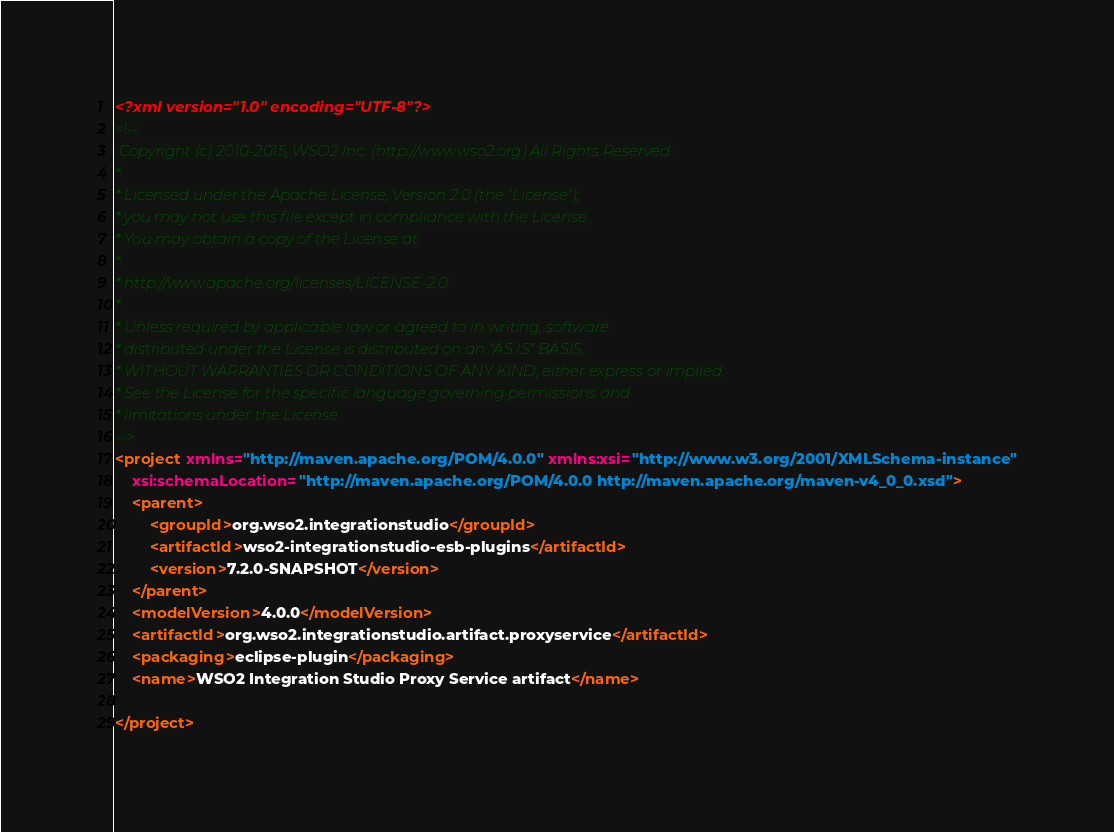Convert code to text. <code><loc_0><loc_0><loc_500><loc_500><_XML_><?xml version="1.0" encoding="UTF-8"?>
<!--
 Copyright (c) 2010-2015, WSO2 Inc. (http://www.wso2.org) All Rights Reserved.
*
* Licensed under the Apache License, Version 2.0 (the "License");
* you may not use this file except in compliance with the License.
* You may obtain a copy of the License at
*
* http://www.apache.org/licenses/LICENSE-2.0
*
* Unless required by applicable law or agreed to in writing, software
* distributed under the License is distributed on an "AS IS" BASIS,
* WITHOUT WARRANTIES OR CONDITIONS OF ANY KIND, either express or implied.
* See the License for the specific language governing permissions and
* limitations under the License.
-->
<project xmlns="http://maven.apache.org/POM/4.0.0" xmlns:xsi="http://www.w3.org/2001/XMLSchema-instance"
	xsi:schemaLocation="http://maven.apache.org/POM/4.0.0 http://maven.apache.org/maven-v4_0_0.xsd">
	<parent>
		<groupId>org.wso2.integrationstudio</groupId>
		<artifactId>wso2-integrationstudio-esb-plugins</artifactId>
		<version>7.2.0-SNAPSHOT</version>
	</parent>
	<modelVersion>4.0.0</modelVersion>
	<artifactId>org.wso2.integrationstudio.artifact.proxyservice</artifactId>
	<packaging>eclipse-plugin</packaging>
	<name>WSO2 Integration Studio Proxy Service artifact</name>

</project>
</code> 